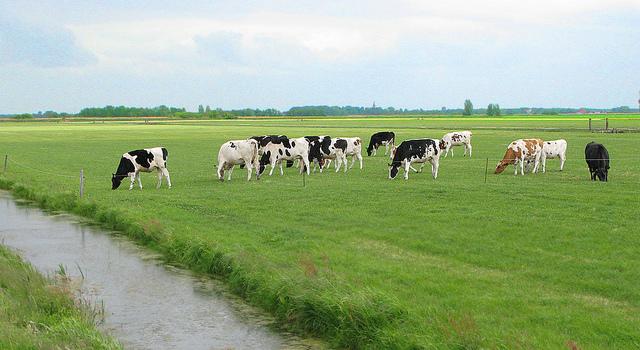What animals are this?
Short answer required. Cows. Is there any water in the photo?
Concise answer only. Yes. How many cows are shown?
Be succinct. 12. 